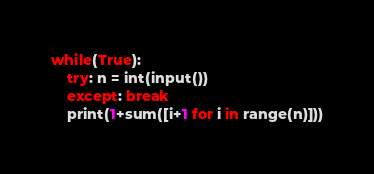<code> <loc_0><loc_0><loc_500><loc_500><_Python_>while(True):
    try: n = int(input())
    except: break
    print(1+sum([i+1 for i in range(n)]))
</code> 